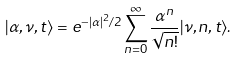Convert formula to latex. <formula><loc_0><loc_0><loc_500><loc_500>| \alpha , \nu , t \rangle = e ^ { - | \alpha | ^ { 2 } / 2 } \sum _ { n = 0 } ^ { \infty } \frac { \alpha ^ { n } } { \sqrt { n ! } } | \nu , n , t \rangle .</formula> 